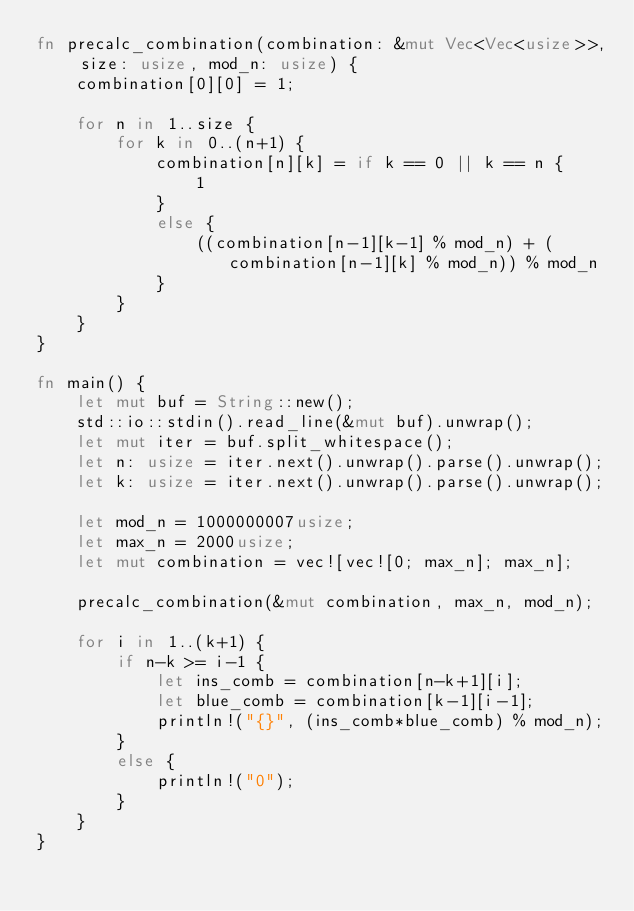Convert code to text. <code><loc_0><loc_0><loc_500><loc_500><_Rust_>fn precalc_combination(combination: &mut Vec<Vec<usize>>, size: usize, mod_n: usize) {
    combination[0][0] = 1;

    for n in 1..size {
        for k in 0..(n+1) {
            combination[n][k] = if k == 0 || k == n {
                1
            }
            else {
                ((combination[n-1][k-1] % mod_n) + (combination[n-1][k] % mod_n)) % mod_n
            }
        }
    }
}

fn main() {
    let mut buf = String::new();
    std::io::stdin().read_line(&mut buf).unwrap();
    let mut iter = buf.split_whitespace();
    let n: usize = iter.next().unwrap().parse().unwrap();
    let k: usize = iter.next().unwrap().parse().unwrap();

    let mod_n = 1000000007usize;
    let max_n = 2000usize;
    let mut combination = vec![vec![0; max_n]; max_n];

    precalc_combination(&mut combination, max_n, mod_n);

    for i in 1..(k+1) {
        if n-k >= i-1 {
            let ins_comb = combination[n-k+1][i];
            let blue_comb = combination[k-1][i-1];
            println!("{}", (ins_comb*blue_comb) % mod_n);
        }
        else {
            println!("0");
        }
    }
}</code> 